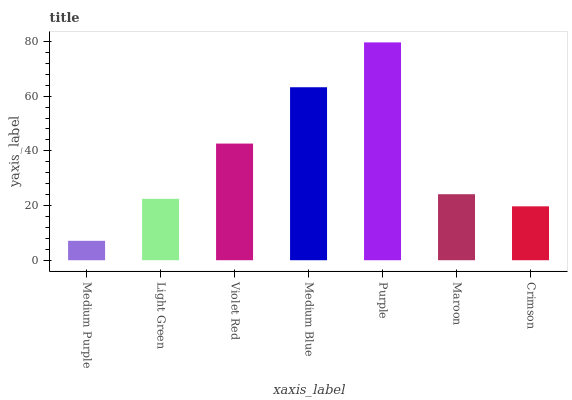Is Medium Purple the minimum?
Answer yes or no. Yes. Is Purple the maximum?
Answer yes or no. Yes. Is Light Green the minimum?
Answer yes or no. No. Is Light Green the maximum?
Answer yes or no. No. Is Light Green greater than Medium Purple?
Answer yes or no. Yes. Is Medium Purple less than Light Green?
Answer yes or no. Yes. Is Medium Purple greater than Light Green?
Answer yes or no. No. Is Light Green less than Medium Purple?
Answer yes or no. No. Is Maroon the high median?
Answer yes or no. Yes. Is Maroon the low median?
Answer yes or no. Yes. Is Light Green the high median?
Answer yes or no. No. Is Purple the low median?
Answer yes or no. No. 